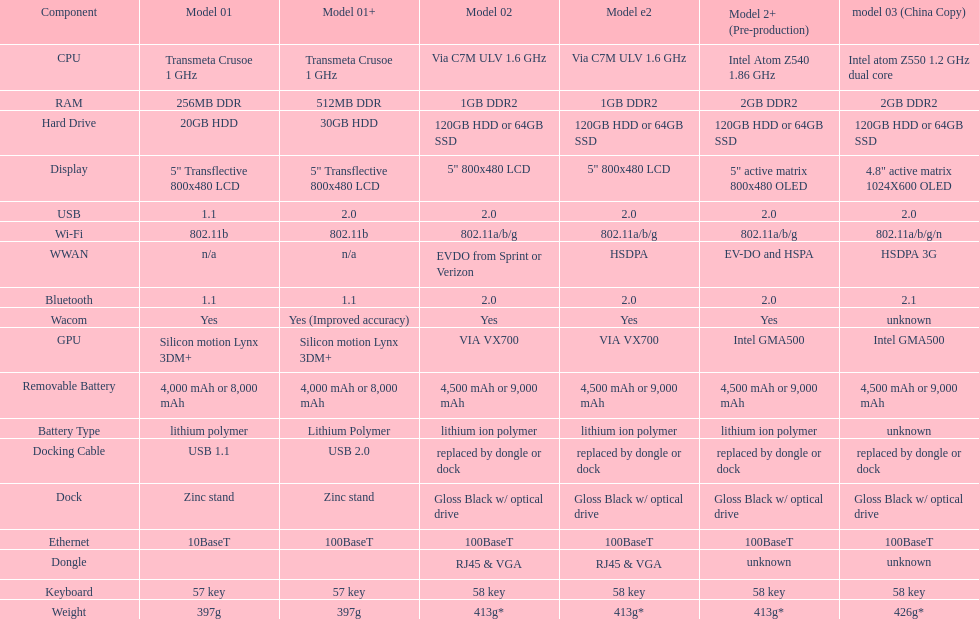What is the component before usb? Display. Parse the full table. {'header': ['Component', 'Model 01', 'Model 01+', 'Model 02', 'Model e2', 'Model 2+ (Pre-production)', 'model 03 (China Copy)'], 'rows': [['CPU', 'Transmeta Crusoe 1\xa0GHz', 'Transmeta Crusoe 1\xa0GHz', 'Via C7M ULV 1.6\xa0GHz', 'Via C7M ULV 1.6\xa0GHz', 'Intel Atom Z540 1.86\xa0GHz', 'Intel atom Z550 1.2\xa0GHz dual core'], ['RAM', '256MB DDR', '512MB DDR', '1GB DDR2', '1GB DDR2', '2GB DDR2', '2GB DDR2'], ['Hard Drive', '20GB HDD', '30GB HDD', '120GB HDD or 64GB SSD', '120GB HDD or 64GB SSD', '120GB HDD or 64GB SSD', '120GB HDD or 64GB SSD'], ['Display', '5" Transflective 800x480 LCD', '5" Transflective 800x480 LCD', '5" 800x480 LCD', '5" 800x480 LCD', '5" active matrix 800x480 OLED', '4.8" active matrix 1024X600 OLED'], ['USB', '1.1', '2.0', '2.0', '2.0', '2.0', '2.0'], ['Wi-Fi', '802.11b', '802.11b', '802.11a/b/g', '802.11a/b/g', '802.11a/b/g', '802.11a/b/g/n'], ['WWAN', 'n/a', 'n/a', 'EVDO from Sprint or Verizon', 'HSDPA', 'EV-DO and HSPA', 'HSDPA 3G'], ['Bluetooth', '1.1', '1.1', '2.0', '2.0', '2.0', '2.1'], ['Wacom', 'Yes', 'Yes (Improved accuracy)', 'Yes', 'Yes', 'Yes', 'unknown'], ['GPU', 'Silicon motion Lynx 3DM+', 'Silicon motion Lynx 3DM+', 'VIA VX700', 'VIA VX700', 'Intel GMA500', 'Intel GMA500'], ['Removable Battery', '4,000 mAh or 8,000 mAh', '4,000 mAh or 8,000 mAh', '4,500 mAh or 9,000 mAh', '4,500 mAh or 9,000 mAh', '4,500 mAh or 9,000 mAh', '4,500 mAh or 9,000 mAh'], ['Battery Type', 'lithium polymer', 'Lithium Polymer', 'lithium ion polymer', 'lithium ion polymer', 'lithium ion polymer', 'unknown'], ['Docking Cable', 'USB 1.1', 'USB 2.0', 'replaced by dongle or dock', 'replaced by dongle or dock', 'replaced by dongle or dock', 'replaced by dongle or dock'], ['Dock', 'Zinc stand', 'Zinc stand', 'Gloss Black w/ optical drive', 'Gloss Black w/ optical drive', 'Gloss Black w/ optical drive', 'Gloss Black w/ optical drive'], ['Ethernet', '10BaseT', '100BaseT', '100BaseT', '100BaseT', '100BaseT', '100BaseT'], ['Dongle', '', '', 'RJ45 & VGA', 'RJ45 & VGA', 'unknown', 'unknown'], ['Keyboard', '57 key', '57 key', '58 key', '58 key', '58 key', '58 key'], ['Weight', '397g', '397g', '413g*', '413g*', '413g*', '426g*']]} 